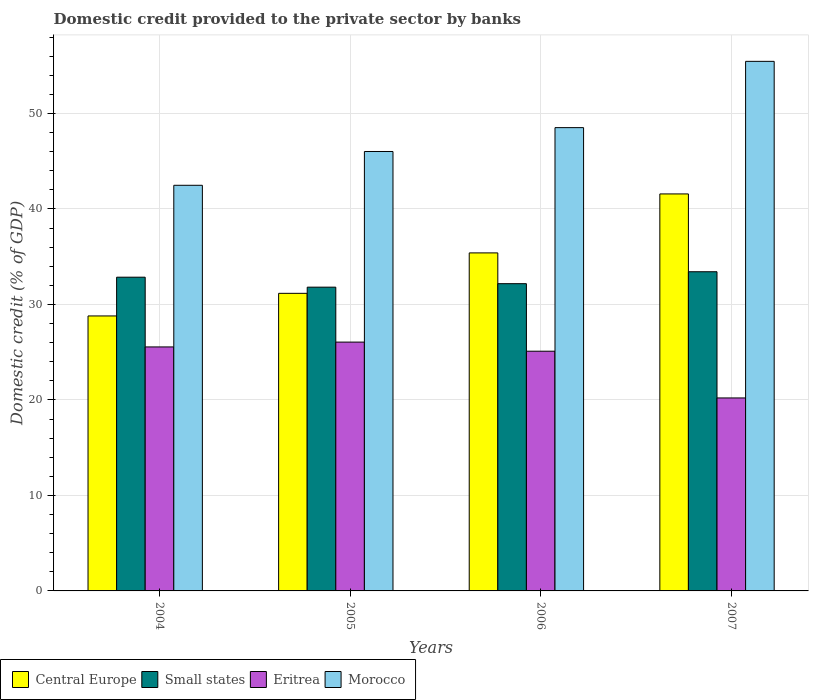Are the number of bars per tick equal to the number of legend labels?
Ensure brevity in your answer.  Yes. Are the number of bars on each tick of the X-axis equal?
Offer a terse response. Yes. How many bars are there on the 2nd tick from the left?
Keep it short and to the point. 4. How many bars are there on the 4th tick from the right?
Offer a terse response. 4. What is the label of the 4th group of bars from the left?
Provide a succinct answer. 2007. What is the domestic credit provided to the private sector by banks in Morocco in 2004?
Provide a succinct answer. 42.48. Across all years, what is the maximum domestic credit provided to the private sector by banks in Central Europe?
Your response must be concise. 41.58. Across all years, what is the minimum domestic credit provided to the private sector by banks in Eritrea?
Provide a short and direct response. 20.21. In which year was the domestic credit provided to the private sector by banks in Eritrea minimum?
Your response must be concise. 2007. What is the total domestic credit provided to the private sector by banks in Eritrea in the graph?
Offer a terse response. 96.92. What is the difference between the domestic credit provided to the private sector by banks in Morocco in 2005 and that in 2006?
Your answer should be very brief. -2.5. What is the difference between the domestic credit provided to the private sector by banks in Morocco in 2007 and the domestic credit provided to the private sector by banks in Central Europe in 2005?
Keep it short and to the point. 24.29. What is the average domestic credit provided to the private sector by banks in Central Europe per year?
Ensure brevity in your answer.  34.23. In the year 2007, what is the difference between the domestic credit provided to the private sector by banks in Small states and domestic credit provided to the private sector by banks in Morocco?
Make the answer very short. -22.03. What is the ratio of the domestic credit provided to the private sector by banks in Central Europe in 2006 to that in 2007?
Offer a very short reply. 0.85. Is the domestic credit provided to the private sector by banks in Central Europe in 2004 less than that in 2007?
Your answer should be compact. Yes. Is the difference between the domestic credit provided to the private sector by banks in Small states in 2006 and 2007 greater than the difference between the domestic credit provided to the private sector by banks in Morocco in 2006 and 2007?
Your response must be concise. Yes. What is the difference between the highest and the second highest domestic credit provided to the private sector by banks in Eritrea?
Offer a terse response. 0.51. What is the difference between the highest and the lowest domestic credit provided to the private sector by banks in Morocco?
Make the answer very short. 12.98. Is the sum of the domestic credit provided to the private sector by banks in Central Europe in 2004 and 2006 greater than the maximum domestic credit provided to the private sector by banks in Small states across all years?
Offer a very short reply. Yes. What does the 2nd bar from the left in 2004 represents?
Provide a short and direct response. Small states. What does the 3rd bar from the right in 2006 represents?
Make the answer very short. Small states. Is it the case that in every year, the sum of the domestic credit provided to the private sector by banks in Eritrea and domestic credit provided to the private sector by banks in Small states is greater than the domestic credit provided to the private sector by banks in Morocco?
Offer a very short reply. No. Are all the bars in the graph horizontal?
Ensure brevity in your answer.  No. Does the graph contain any zero values?
Give a very brief answer. No. Does the graph contain grids?
Make the answer very short. Yes. Where does the legend appear in the graph?
Your answer should be very brief. Bottom left. How are the legend labels stacked?
Your response must be concise. Horizontal. What is the title of the graph?
Offer a terse response. Domestic credit provided to the private sector by banks. Does "Singapore" appear as one of the legend labels in the graph?
Your answer should be very brief. No. What is the label or title of the Y-axis?
Keep it short and to the point. Domestic credit (% of GDP). What is the Domestic credit (% of GDP) in Central Europe in 2004?
Offer a terse response. 28.8. What is the Domestic credit (% of GDP) in Small states in 2004?
Offer a terse response. 32.86. What is the Domestic credit (% of GDP) in Eritrea in 2004?
Your answer should be compact. 25.55. What is the Domestic credit (% of GDP) in Morocco in 2004?
Offer a very short reply. 42.48. What is the Domestic credit (% of GDP) of Central Europe in 2005?
Offer a very short reply. 31.17. What is the Domestic credit (% of GDP) in Small states in 2005?
Give a very brief answer. 31.81. What is the Domestic credit (% of GDP) of Eritrea in 2005?
Offer a terse response. 26.06. What is the Domestic credit (% of GDP) of Morocco in 2005?
Offer a very short reply. 46.02. What is the Domestic credit (% of GDP) of Central Europe in 2006?
Give a very brief answer. 35.4. What is the Domestic credit (% of GDP) in Small states in 2006?
Provide a short and direct response. 32.18. What is the Domestic credit (% of GDP) of Eritrea in 2006?
Your answer should be very brief. 25.1. What is the Domestic credit (% of GDP) in Morocco in 2006?
Keep it short and to the point. 48.52. What is the Domestic credit (% of GDP) in Central Europe in 2007?
Offer a very short reply. 41.58. What is the Domestic credit (% of GDP) in Small states in 2007?
Ensure brevity in your answer.  33.43. What is the Domestic credit (% of GDP) of Eritrea in 2007?
Ensure brevity in your answer.  20.21. What is the Domestic credit (% of GDP) of Morocco in 2007?
Give a very brief answer. 55.46. Across all years, what is the maximum Domestic credit (% of GDP) in Central Europe?
Your answer should be compact. 41.58. Across all years, what is the maximum Domestic credit (% of GDP) of Small states?
Your response must be concise. 33.43. Across all years, what is the maximum Domestic credit (% of GDP) of Eritrea?
Keep it short and to the point. 26.06. Across all years, what is the maximum Domestic credit (% of GDP) of Morocco?
Provide a succinct answer. 55.46. Across all years, what is the minimum Domestic credit (% of GDP) of Central Europe?
Your answer should be very brief. 28.8. Across all years, what is the minimum Domestic credit (% of GDP) of Small states?
Ensure brevity in your answer.  31.81. Across all years, what is the minimum Domestic credit (% of GDP) of Eritrea?
Your answer should be very brief. 20.21. Across all years, what is the minimum Domestic credit (% of GDP) of Morocco?
Your answer should be very brief. 42.48. What is the total Domestic credit (% of GDP) of Central Europe in the graph?
Your answer should be compact. 136.94. What is the total Domestic credit (% of GDP) of Small states in the graph?
Your response must be concise. 130.27. What is the total Domestic credit (% of GDP) of Eritrea in the graph?
Offer a terse response. 96.92. What is the total Domestic credit (% of GDP) in Morocco in the graph?
Make the answer very short. 192.48. What is the difference between the Domestic credit (% of GDP) in Central Europe in 2004 and that in 2005?
Offer a very short reply. -2.37. What is the difference between the Domestic credit (% of GDP) in Small states in 2004 and that in 2005?
Provide a succinct answer. 1.04. What is the difference between the Domestic credit (% of GDP) of Eritrea in 2004 and that in 2005?
Provide a short and direct response. -0.51. What is the difference between the Domestic credit (% of GDP) in Morocco in 2004 and that in 2005?
Offer a terse response. -3.54. What is the difference between the Domestic credit (% of GDP) of Central Europe in 2004 and that in 2006?
Ensure brevity in your answer.  -6.6. What is the difference between the Domestic credit (% of GDP) of Small states in 2004 and that in 2006?
Your answer should be very brief. 0.68. What is the difference between the Domestic credit (% of GDP) of Eritrea in 2004 and that in 2006?
Your response must be concise. 0.45. What is the difference between the Domestic credit (% of GDP) in Morocco in 2004 and that in 2006?
Make the answer very short. -6.04. What is the difference between the Domestic credit (% of GDP) of Central Europe in 2004 and that in 2007?
Your answer should be very brief. -12.78. What is the difference between the Domestic credit (% of GDP) of Small states in 2004 and that in 2007?
Make the answer very short. -0.57. What is the difference between the Domestic credit (% of GDP) of Eritrea in 2004 and that in 2007?
Your answer should be compact. 5.34. What is the difference between the Domestic credit (% of GDP) of Morocco in 2004 and that in 2007?
Give a very brief answer. -12.98. What is the difference between the Domestic credit (% of GDP) of Central Europe in 2005 and that in 2006?
Offer a terse response. -4.23. What is the difference between the Domestic credit (% of GDP) in Small states in 2005 and that in 2006?
Provide a short and direct response. -0.36. What is the difference between the Domestic credit (% of GDP) of Eritrea in 2005 and that in 2006?
Keep it short and to the point. 0.95. What is the difference between the Domestic credit (% of GDP) in Morocco in 2005 and that in 2006?
Your answer should be compact. -2.5. What is the difference between the Domestic credit (% of GDP) in Central Europe in 2005 and that in 2007?
Make the answer very short. -10.41. What is the difference between the Domestic credit (% of GDP) in Small states in 2005 and that in 2007?
Your answer should be compact. -1.61. What is the difference between the Domestic credit (% of GDP) of Eritrea in 2005 and that in 2007?
Offer a very short reply. 5.85. What is the difference between the Domestic credit (% of GDP) of Morocco in 2005 and that in 2007?
Make the answer very short. -9.44. What is the difference between the Domestic credit (% of GDP) in Central Europe in 2006 and that in 2007?
Offer a terse response. -6.18. What is the difference between the Domestic credit (% of GDP) in Small states in 2006 and that in 2007?
Offer a very short reply. -1.25. What is the difference between the Domestic credit (% of GDP) in Eritrea in 2006 and that in 2007?
Keep it short and to the point. 4.89. What is the difference between the Domestic credit (% of GDP) of Morocco in 2006 and that in 2007?
Provide a succinct answer. -6.94. What is the difference between the Domestic credit (% of GDP) of Central Europe in 2004 and the Domestic credit (% of GDP) of Small states in 2005?
Your answer should be compact. -3.01. What is the difference between the Domestic credit (% of GDP) of Central Europe in 2004 and the Domestic credit (% of GDP) of Eritrea in 2005?
Offer a terse response. 2.74. What is the difference between the Domestic credit (% of GDP) in Central Europe in 2004 and the Domestic credit (% of GDP) in Morocco in 2005?
Offer a terse response. -17.22. What is the difference between the Domestic credit (% of GDP) of Small states in 2004 and the Domestic credit (% of GDP) of Eritrea in 2005?
Ensure brevity in your answer.  6.8. What is the difference between the Domestic credit (% of GDP) of Small states in 2004 and the Domestic credit (% of GDP) of Morocco in 2005?
Offer a very short reply. -13.16. What is the difference between the Domestic credit (% of GDP) of Eritrea in 2004 and the Domestic credit (% of GDP) of Morocco in 2005?
Offer a terse response. -20.47. What is the difference between the Domestic credit (% of GDP) in Central Europe in 2004 and the Domestic credit (% of GDP) in Small states in 2006?
Offer a very short reply. -3.38. What is the difference between the Domestic credit (% of GDP) of Central Europe in 2004 and the Domestic credit (% of GDP) of Eritrea in 2006?
Your answer should be compact. 3.69. What is the difference between the Domestic credit (% of GDP) of Central Europe in 2004 and the Domestic credit (% of GDP) of Morocco in 2006?
Keep it short and to the point. -19.72. What is the difference between the Domestic credit (% of GDP) of Small states in 2004 and the Domestic credit (% of GDP) of Eritrea in 2006?
Offer a very short reply. 7.75. What is the difference between the Domestic credit (% of GDP) in Small states in 2004 and the Domestic credit (% of GDP) in Morocco in 2006?
Your response must be concise. -15.66. What is the difference between the Domestic credit (% of GDP) in Eritrea in 2004 and the Domestic credit (% of GDP) in Morocco in 2006?
Offer a terse response. -22.97. What is the difference between the Domestic credit (% of GDP) of Central Europe in 2004 and the Domestic credit (% of GDP) of Small states in 2007?
Your answer should be very brief. -4.63. What is the difference between the Domestic credit (% of GDP) of Central Europe in 2004 and the Domestic credit (% of GDP) of Eritrea in 2007?
Your response must be concise. 8.59. What is the difference between the Domestic credit (% of GDP) in Central Europe in 2004 and the Domestic credit (% of GDP) in Morocco in 2007?
Provide a succinct answer. -26.66. What is the difference between the Domestic credit (% of GDP) of Small states in 2004 and the Domestic credit (% of GDP) of Eritrea in 2007?
Ensure brevity in your answer.  12.64. What is the difference between the Domestic credit (% of GDP) in Small states in 2004 and the Domestic credit (% of GDP) in Morocco in 2007?
Your answer should be compact. -22.6. What is the difference between the Domestic credit (% of GDP) of Eritrea in 2004 and the Domestic credit (% of GDP) of Morocco in 2007?
Provide a succinct answer. -29.91. What is the difference between the Domestic credit (% of GDP) in Central Europe in 2005 and the Domestic credit (% of GDP) in Small states in 2006?
Keep it short and to the point. -1.01. What is the difference between the Domestic credit (% of GDP) in Central Europe in 2005 and the Domestic credit (% of GDP) in Eritrea in 2006?
Your answer should be compact. 6.06. What is the difference between the Domestic credit (% of GDP) in Central Europe in 2005 and the Domestic credit (% of GDP) in Morocco in 2006?
Your response must be concise. -17.35. What is the difference between the Domestic credit (% of GDP) of Small states in 2005 and the Domestic credit (% of GDP) of Eritrea in 2006?
Offer a terse response. 6.71. What is the difference between the Domestic credit (% of GDP) of Small states in 2005 and the Domestic credit (% of GDP) of Morocco in 2006?
Your answer should be compact. -16.71. What is the difference between the Domestic credit (% of GDP) of Eritrea in 2005 and the Domestic credit (% of GDP) of Morocco in 2006?
Your answer should be very brief. -22.46. What is the difference between the Domestic credit (% of GDP) of Central Europe in 2005 and the Domestic credit (% of GDP) of Small states in 2007?
Your answer should be very brief. -2.26. What is the difference between the Domestic credit (% of GDP) of Central Europe in 2005 and the Domestic credit (% of GDP) of Eritrea in 2007?
Ensure brevity in your answer.  10.95. What is the difference between the Domestic credit (% of GDP) of Central Europe in 2005 and the Domestic credit (% of GDP) of Morocco in 2007?
Keep it short and to the point. -24.29. What is the difference between the Domestic credit (% of GDP) of Small states in 2005 and the Domestic credit (% of GDP) of Eritrea in 2007?
Make the answer very short. 11.6. What is the difference between the Domestic credit (% of GDP) in Small states in 2005 and the Domestic credit (% of GDP) in Morocco in 2007?
Give a very brief answer. -23.65. What is the difference between the Domestic credit (% of GDP) of Eritrea in 2005 and the Domestic credit (% of GDP) of Morocco in 2007?
Keep it short and to the point. -29.4. What is the difference between the Domestic credit (% of GDP) of Central Europe in 2006 and the Domestic credit (% of GDP) of Small states in 2007?
Your response must be concise. 1.97. What is the difference between the Domestic credit (% of GDP) in Central Europe in 2006 and the Domestic credit (% of GDP) in Eritrea in 2007?
Provide a short and direct response. 15.19. What is the difference between the Domestic credit (% of GDP) of Central Europe in 2006 and the Domestic credit (% of GDP) of Morocco in 2007?
Provide a succinct answer. -20.06. What is the difference between the Domestic credit (% of GDP) in Small states in 2006 and the Domestic credit (% of GDP) in Eritrea in 2007?
Offer a very short reply. 11.97. What is the difference between the Domestic credit (% of GDP) of Small states in 2006 and the Domestic credit (% of GDP) of Morocco in 2007?
Your answer should be compact. -23.28. What is the difference between the Domestic credit (% of GDP) in Eritrea in 2006 and the Domestic credit (% of GDP) in Morocco in 2007?
Your answer should be compact. -30.36. What is the average Domestic credit (% of GDP) in Central Europe per year?
Give a very brief answer. 34.23. What is the average Domestic credit (% of GDP) in Small states per year?
Provide a short and direct response. 32.57. What is the average Domestic credit (% of GDP) in Eritrea per year?
Give a very brief answer. 24.23. What is the average Domestic credit (% of GDP) in Morocco per year?
Give a very brief answer. 48.12. In the year 2004, what is the difference between the Domestic credit (% of GDP) of Central Europe and Domestic credit (% of GDP) of Small states?
Make the answer very short. -4.06. In the year 2004, what is the difference between the Domestic credit (% of GDP) in Central Europe and Domestic credit (% of GDP) in Eritrea?
Ensure brevity in your answer.  3.24. In the year 2004, what is the difference between the Domestic credit (% of GDP) in Central Europe and Domestic credit (% of GDP) in Morocco?
Provide a short and direct response. -13.68. In the year 2004, what is the difference between the Domestic credit (% of GDP) of Small states and Domestic credit (% of GDP) of Eritrea?
Provide a succinct answer. 7.3. In the year 2004, what is the difference between the Domestic credit (% of GDP) of Small states and Domestic credit (% of GDP) of Morocco?
Offer a very short reply. -9.62. In the year 2004, what is the difference between the Domestic credit (% of GDP) in Eritrea and Domestic credit (% of GDP) in Morocco?
Offer a very short reply. -16.93. In the year 2005, what is the difference between the Domestic credit (% of GDP) in Central Europe and Domestic credit (% of GDP) in Small states?
Your answer should be compact. -0.65. In the year 2005, what is the difference between the Domestic credit (% of GDP) of Central Europe and Domestic credit (% of GDP) of Eritrea?
Your answer should be very brief. 5.11. In the year 2005, what is the difference between the Domestic credit (% of GDP) of Central Europe and Domestic credit (% of GDP) of Morocco?
Provide a succinct answer. -14.85. In the year 2005, what is the difference between the Domestic credit (% of GDP) of Small states and Domestic credit (% of GDP) of Eritrea?
Keep it short and to the point. 5.75. In the year 2005, what is the difference between the Domestic credit (% of GDP) of Small states and Domestic credit (% of GDP) of Morocco?
Offer a terse response. -14.21. In the year 2005, what is the difference between the Domestic credit (% of GDP) of Eritrea and Domestic credit (% of GDP) of Morocco?
Offer a very short reply. -19.96. In the year 2006, what is the difference between the Domestic credit (% of GDP) of Central Europe and Domestic credit (% of GDP) of Small states?
Offer a very short reply. 3.22. In the year 2006, what is the difference between the Domestic credit (% of GDP) in Central Europe and Domestic credit (% of GDP) in Eritrea?
Offer a very short reply. 10.3. In the year 2006, what is the difference between the Domestic credit (% of GDP) in Central Europe and Domestic credit (% of GDP) in Morocco?
Make the answer very short. -13.12. In the year 2006, what is the difference between the Domestic credit (% of GDP) in Small states and Domestic credit (% of GDP) in Eritrea?
Keep it short and to the point. 7.07. In the year 2006, what is the difference between the Domestic credit (% of GDP) in Small states and Domestic credit (% of GDP) in Morocco?
Your answer should be very brief. -16.34. In the year 2006, what is the difference between the Domestic credit (% of GDP) of Eritrea and Domestic credit (% of GDP) of Morocco?
Give a very brief answer. -23.42. In the year 2007, what is the difference between the Domestic credit (% of GDP) in Central Europe and Domestic credit (% of GDP) in Small states?
Provide a succinct answer. 8.15. In the year 2007, what is the difference between the Domestic credit (% of GDP) of Central Europe and Domestic credit (% of GDP) of Eritrea?
Provide a succinct answer. 21.37. In the year 2007, what is the difference between the Domestic credit (% of GDP) in Central Europe and Domestic credit (% of GDP) in Morocco?
Make the answer very short. -13.88. In the year 2007, what is the difference between the Domestic credit (% of GDP) in Small states and Domestic credit (% of GDP) in Eritrea?
Your response must be concise. 13.22. In the year 2007, what is the difference between the Domestic credit (% of GDP) of Small states and Domestic credit (% of GDP) of Morocco?
Your answer should be compact. -22.03. In the year 2007, what is the difference between the Domestic credit (% of GDP) of Eritrea and Domestic credit (% of GDP) of Morocco?
Keep it short and to the point. -35.25. What is the ratio of the Domestic credit (% of GDP) of Central Europe in 2004 to that in 2005?
Provide a succinct answer. 0.92. What is the ratio of the Domestic credit (% of GDP) of Small states in 2004 to that in 2005?
Make the answer very short. 1.03. What is the ratio of the Domestic credit (% of GDP) of Eritrea in 2004 to that in 2005?
Provide a short and direct response. 0.98. What is the ratio of the Domestic credit (% of GDP) in Morocco in 2004 to that in 2005?
Your answer should be very brief. 0.92. What is the ratio of the Domestic credit (% of GDP) of Central Europe in 2004 to that in 2006?
Offer a terse response. 0.81. What is the ratio of the Domestic credit (% of GDP) in Small states in 2004 to that in 2006?
Your answer should be compact. 1.02. What is the ratio of the Domestic credit (% of GDP) in Eritrea in 2004 to that in 2006?
Give a very brief answer. 1.02. What is the ratio of the Domestic credit (% of GDP) in Morocco in 2004 to that in 2006?
Make the answer very short. 0.88. What is the ratio of the Domestic credit (% of GDP) in Central Europe in 2004 to that in 2007?
Provide a succinct answer. 0.69. What is the ratio of the Domestic credit (% of GDP) of Small states in 2004 to that in 2007?
Your answer should be very brief. 0.98. What is the ratio of the Domestic credit (% of GDP) of Eritrea in 2004 to that in 2007?
Give a very brief answer. 1.26. What is the ratio of the Domestic credit (% of GDP) of Morocco in 2004 to that in 2007?
Keep it short and to the point. 0.77. What is the ratio of the Domestic credit (% of GDP) in Central Europe in 2005 to that in 2006?
Your answer should be very brief. 0.88. What is the ratio of the Domestic credit (% of GDP) in Small states in 2005 to that in 2006?
Make the answer very short. 0.99. What is the ratio of the Domestic credit (% of GDP) in Eritrea in 2005 to that in 2006?
Offer a very short reply. 1.04. What is the ratio of the Domestic credit (% of GDP) in Morocco in 2005 to that in 2006?
Make the answer very short. 0.95. What is the ratio of the Domestic credit (% of GDP) in Central Europe in 2005 to that in 2007?
Offer a very short reply. 0.75. What is the ratio of the Domestic credit (% of GDP) of Small states in 2005 to that in 2007?
Provide a succinct answer. 0.95. What is the ratio of the Domestic credit (% of GDP) in Eritrea in 2005 to that in 2007?
Provide a succinct answer. 1.29. What is the ratio of the Domestic credit (% of GDP) of Morocco in 2005 to that in 2007?
Provide a succinct answer. 0.83. What is the ratio of the Domestic credit (% of GDP) of Central Europe in 2006 to that in 2007?
Offer a very short reply. 0.85. What is the ratio of the Domestic credit (% of GDP) of Small states in 2006 to that in 2007?
Your answer should be compact. 0.96. What is the ratio of the Domestic credit (% of GDP) of Eritrea in 2006 to that in 2007?
Ensure brevity in your answer.  1.24. What is the ratio of the Domestic credit (% of GDP) in Morocco in 2006 to that in 2007?
Provide a succinct answer. 0.87. What is the difference between the highest and the second highest Domestic credit (% of GDP) in Central Europe?
Your answer should be very brief. 6.18. What is the difference between the highest and the second highest Domestic credit (% of GDP) of Small states?
Make the answer very short. 0.57. What is the difference between the highest and the second highest Domestic credit (% of GDP) in Eritrea?
Your answer should be very brief. 0.51. What is the difference between the highest and the second highest Domestic credit (% of GDP) in Morocco?
Give a very brief answer. 6.94. What is the difference between the highest and the lowest Domestic credit (% of GDP) of Central Europe?
Ensure brevity in your answer.  12.78. What is the difference between the highest and the lowest Domestic credit (% of GDP) in Small states?
Offer a very short reply. 1.61. What is the difference between the highest and the lowest Domestic credit (% of GDP) of Eritrea?
Your answer should be compact. 5.85. What is the difference between the highest and the lowest Domestic credit (% of GDP) in Morocco?
Your answer should be very brief. 12.98. 